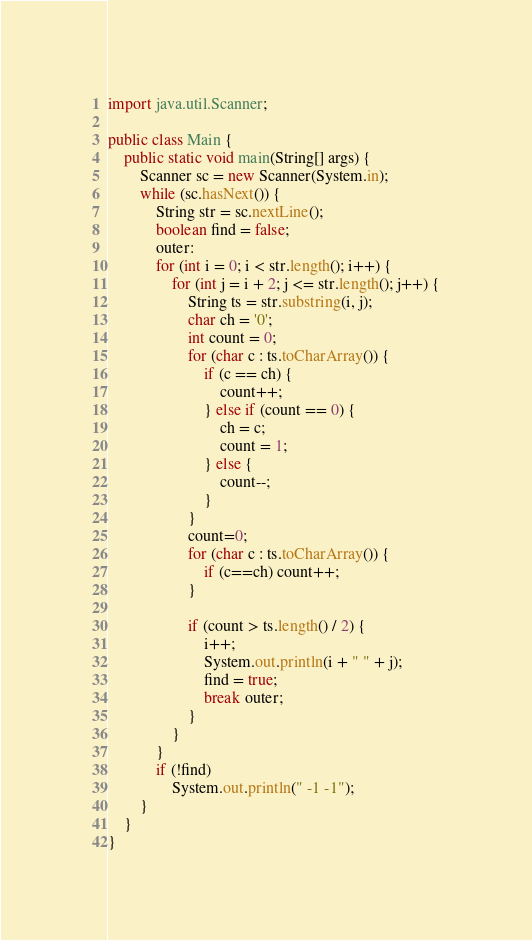Convert code to text. <code><loc_0><loc_0><loc_500><loc_500><_Java_>import java.util.Scanner;

public class Main {
    public static void main(String[] args) {
        Scanner sc = new Scanner(System.in);
        while (sc.hasNext()) {
            String str = sc.nextLine();
            boolean find = false;
            outer:
            for (int i = 0; i < str.length(); i++) {
                for (int j = i + 2; j <= str.length(); j++) {
                    String ts = str.substring(i, j);
                    char ch = '0';
                    int count = 0;
                    for (char c : ts.toCharArray()) {
                        if (c == ch) {
                            count++;
                        } else if (count == 0) {
                            ch = c;
                            count = 1;
                        } else {
                            count--;
                        }
                    }
                    count=0;
                    for (char c : ts.toCharArray()) {
                        if (c==ch) count++;
                    }

                    if (count > ts.length() / 2) {
                        i++;
                        System.out.println(i + " " + j);
                        find = true;
                        break outer;
                    }
                }
            }
            if (!find)
                System.out.println(" -1 -1");
        }
    }
}
</code> 